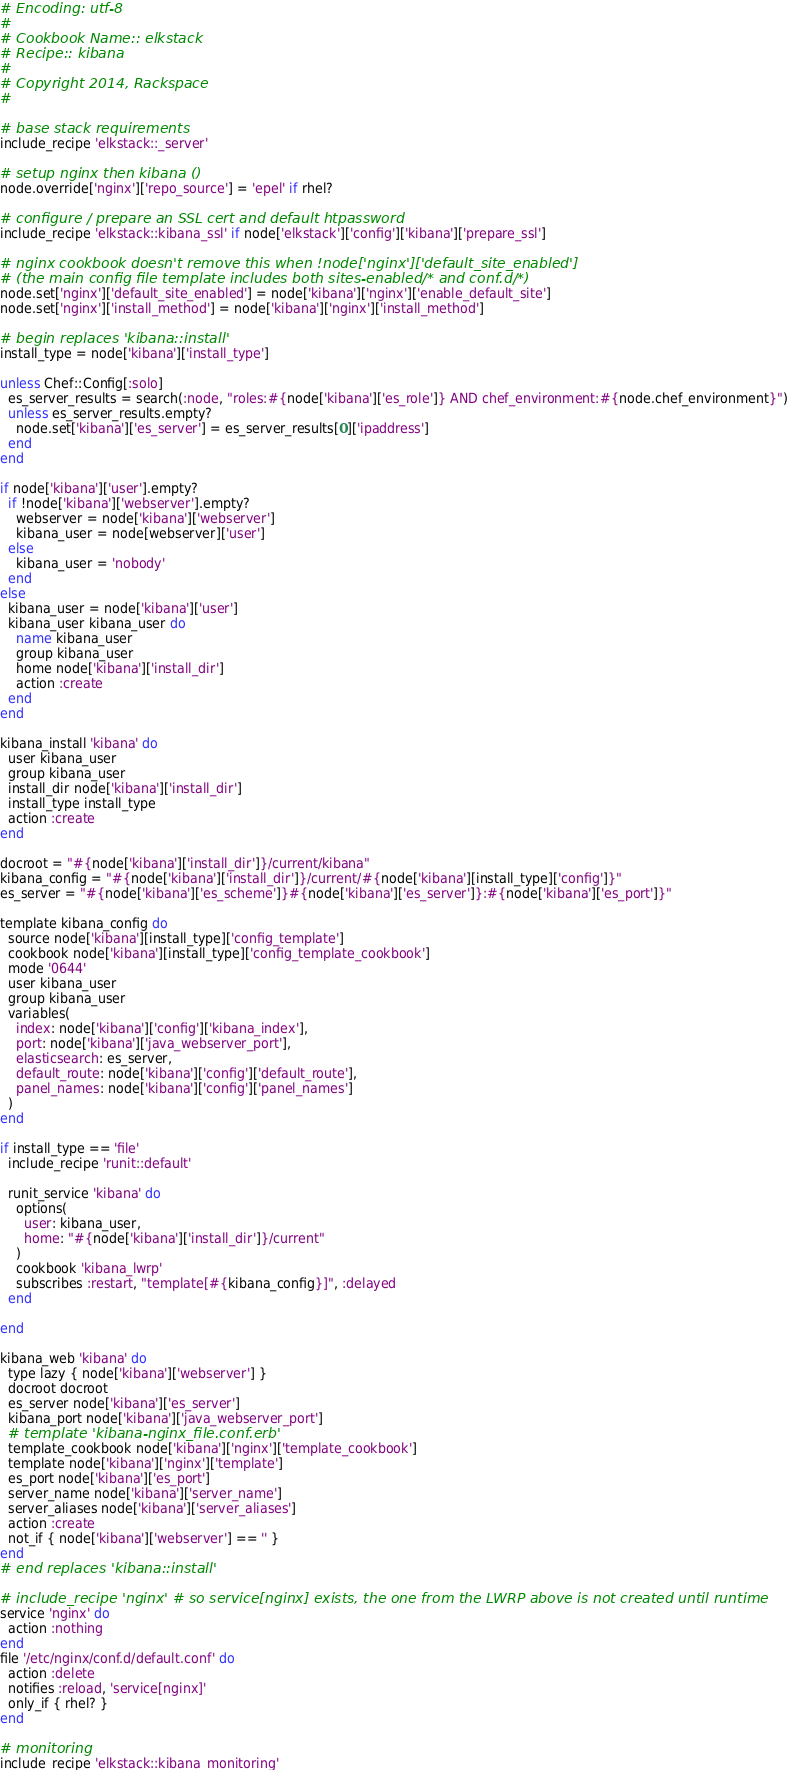Convert code to text. <code><loc_0><loc_0><loc_500><loc_500><_Ruby_># Encoding: utf-8
#
# Cookbook Name:: elkstack
# Recipe:: kibana
#
# Copyright 2014, Rackspace
#

# base stack requirements
include_recipe 'elkstack::_server'

# setup nginx then kibana ()
node.override['nginx']['repo_source'] = 'epel' if rhel?

# configure / prepare an SSL cert and default htpassword
include_recipe 'elkstack::kibana_ssl' if node['elkstack']['config']['kibana']['prepare_ssl']

# nginx cookbook doesn't remove this when !node['nginx']['default_site_enabled']
# (the main config file template includes both sites-enabled/* and conf.d/*)
node.set['nginx']['default_site_enabled'] = node['kibana']['nginx']['enable_default_site']
node.set['nginx']['install_method'] = node['kibana']['nginx']['install_method']

# begin replaces 'kibana::install'
install_type = node['kibana']['install_type']

unless Chef::Config[:solo]
  es_server_results = search(:node, "roles:#{node['kibana']['es_role']} AND chef_environment:#{node.chef_environment}")
  unless es_server_results.empty?
    node.set['kibana']['es_server'] = es_server_results[0]['ipaddress']
  end
end

if node['kibana']['user'].empty?
  if !node['kibana']['webserver'].empty?
    webserver = node['kibana']['webserver']
    kibana_user = node[webserver]['user']
  else
    kibana_user = 'nobody'
  end
else
  kibana_user = node['kibana']['user']
  kibana_user kibana_user do
    name kibana_user
    group kibana_user
    home node['kibana']['install_dir']
    action :create
  end
end

kibana_install 'kibana' do
  user kibana_user
  group kibana_user
  install_dir node['kibana']['install_dir']
  install_type install_type
  action :create
end

docroot = "#{node['kibana']['install_dir']}/current/kibana"
kibana_config = "#{node['kibana']['install_dir']}/current/#{node['kibana'][install_type]['config']}"
es_server = "#{node['kibana']['es_scheme']}#{node['kibana']['es_server']}:#{node['kibana']['es_port']}"

template kibana_config do
  source node['kibana'][install_type]['config_template']
  cookbook node['kibana'][install_type]['config_template_cookbook']
  mode '0644'
  user kibana_user
  group kibana_user
  variables(
    index: node['kibana']['config']['kibana_index'],
    port: node['kibana']['java_webserver_port'],
    elasticsearch: es_server,
    default_route: node['kibana']['config']['default_route'],
    panel_names: node['kibana']['config']['panel_names']
  )
end

if install_type == 'file'
  include_recipe 'runit::default'

  runit_service 'kibana' do
    options(
      user: kibana_user,
      home: "#{node['kibana']['install_dir']}/current"
    )
    cookbook 'kibana_lwrp'
    subscribes :restart, "template[#{kibana_config}]", :delayed
  end

end

kibana_web 'kibana' do
  type lazy { node['kibana']['webserver'] }
  docroot docroot
  es_server node['kibana']['es_server']
  kibana_port node['kibana']['java_webserver_port']
  # template 'kibana-nginx_file.conf.erb'
  template_cookbook node['kibana']['nginx']['template_cookbook']
  template node['kibana']['nginx']['template']
  es_port node['kibana']['es_port']
  server_name node['kibana']['server_name']
  server_aliases node['kibana']['server_aliases']
  action :create
  not_if { node['kibana']['webserver'] == '' }
end
# end replaces 'kibana::install'

# include_recipe 'nginx' # so service[nginx] exists, the one from the LWRP above is not created until runtime
service 'nginx' do
  action :nothing
end
file '/etc/nginx/conf.d/default.conf' do
  action :delete
  notifies :reload, 'service[nginx]'
  only_if { rhel? }
end

# monitoring
include_recipe 'elkstack::kibana_monitoring'
</code> 